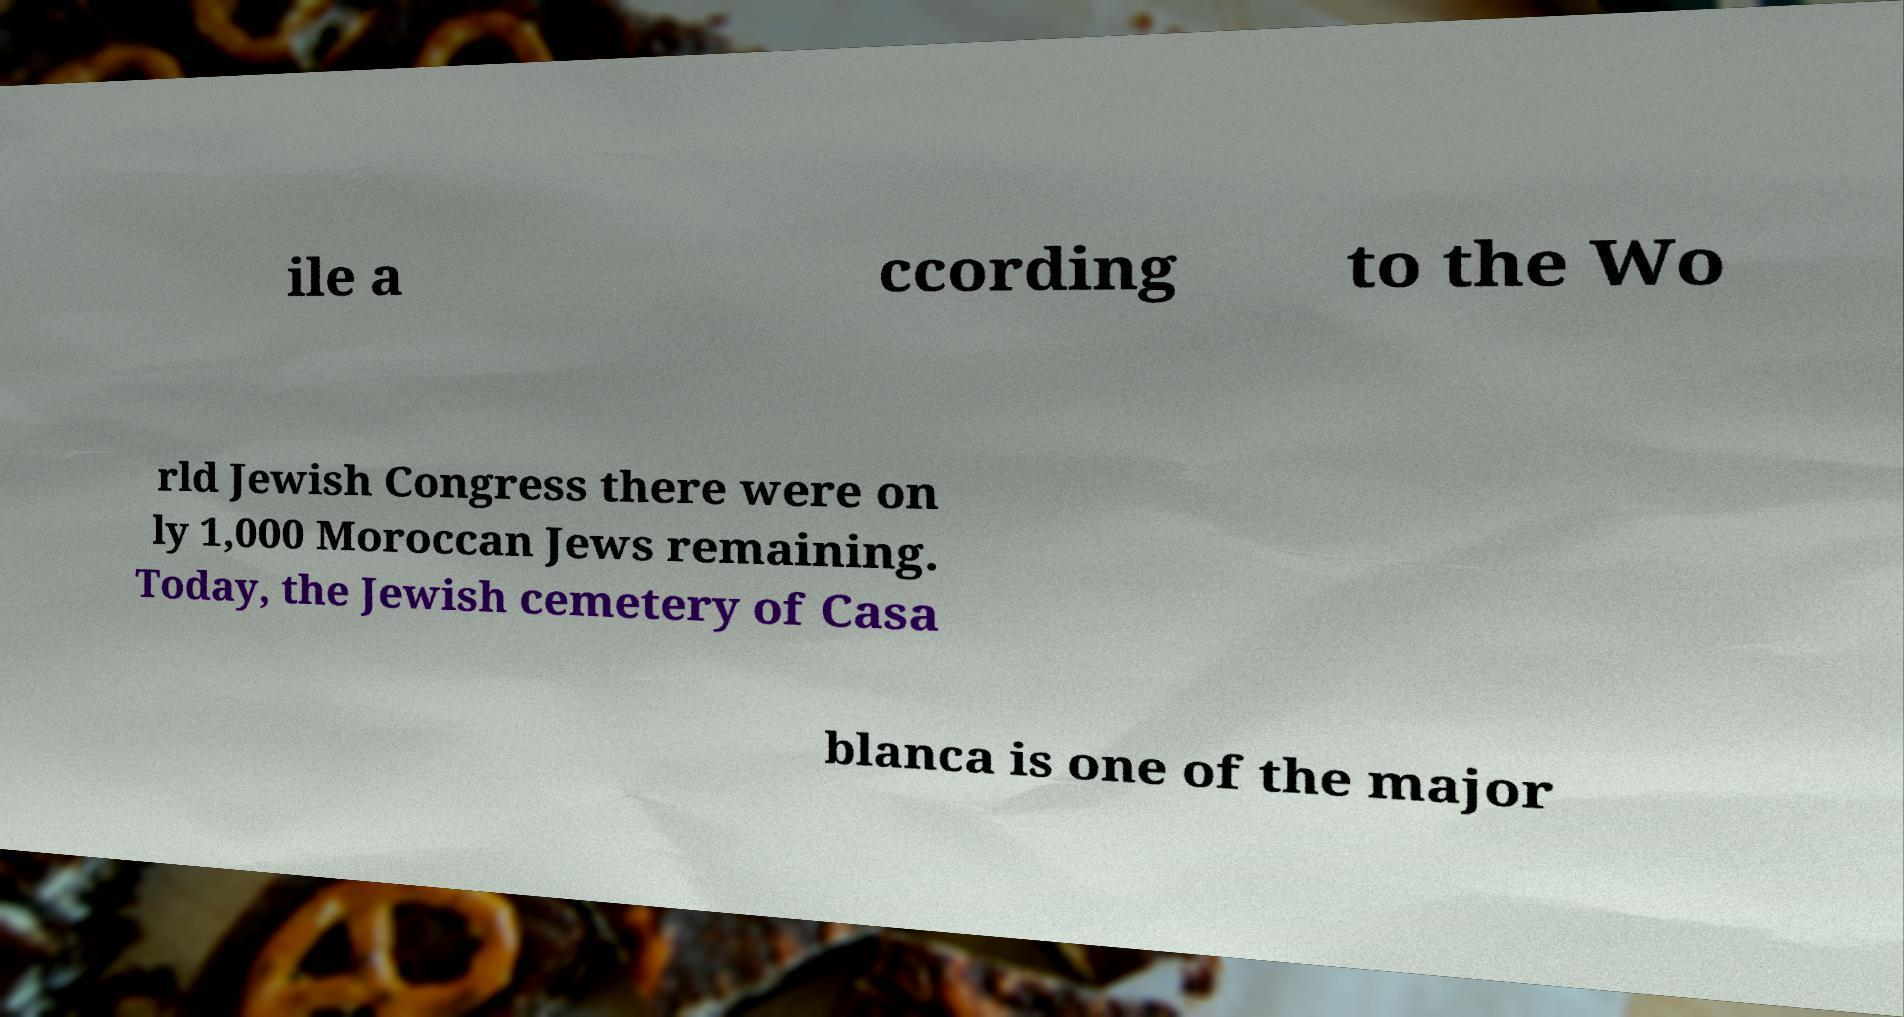Please read and relay the text visible in this image. What does it say? ile a ccording to the Wo rld Jewish Congress there were on ly 1,000 Moroccan Jews remaining. Today, the Jewish cemetery of Casa blanca is one of the major 